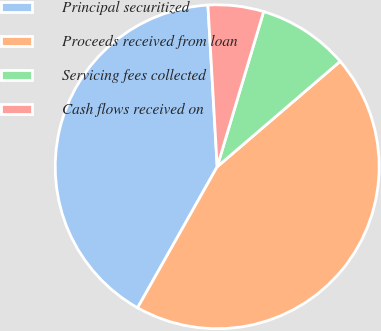Convert chart. <chart><loc_0><loc_0><loc_500><loc_500><pie_chart><fcel>Principal securitized<fcel>Proceeds received from loan<fcel>Servicing fees collected<fcel>Cash flows received on<nl><fcel>40.91%<fcel>44.46%<fcel>9.09%<fcel>5.54%<nl></chart> 